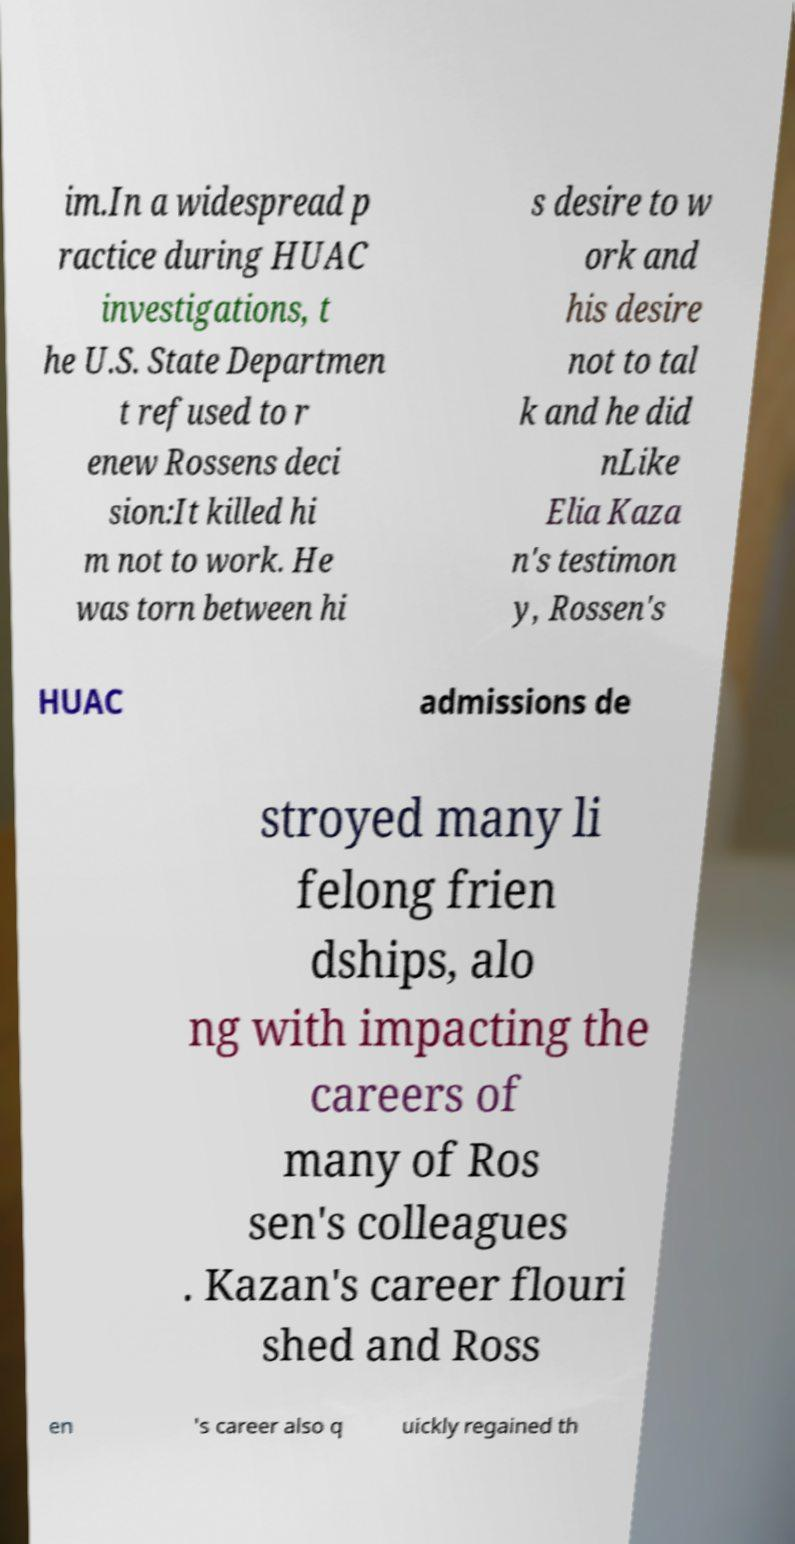Can you read and provide the text displayed in the image?This photo seems to have some interesting text. Can you extract and type it out for me? im.In a widespread p ractice during HUAC investigations, t he U.S. State Departmen t refused to r enew Rossens deci sion:It killed hi m not to work. He was torn between hi s desire to w ork and his desire not to tal k and he did nLike Elia Kaza n's testimon y, Rossen's HUAC admissions de stroyed many li felong frien dships, alo ng with impacting the careers of many of Ros sen's colleagues . Kazan's career flouri shed and Ross en 's career also q uickly regained th 